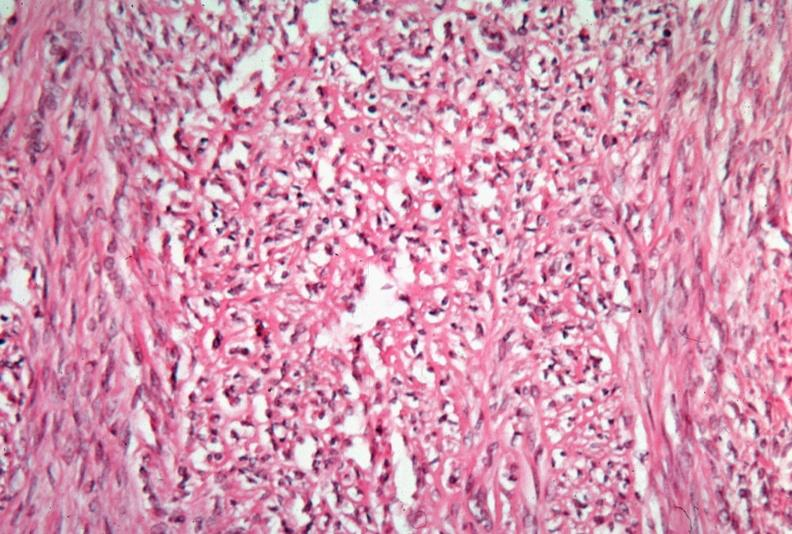what is present?
Answer the question using a single word or phrase. Female reproductive 